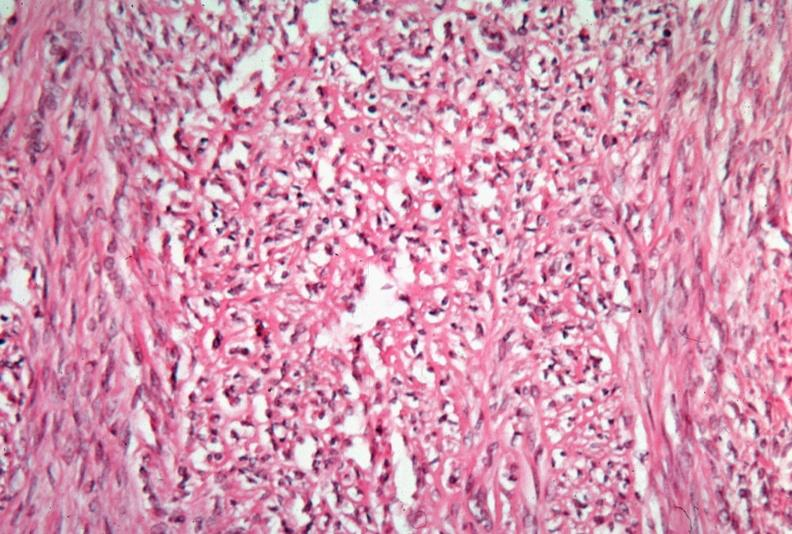what is present?
Answer the question using a single word or phrase. Female reproductive 